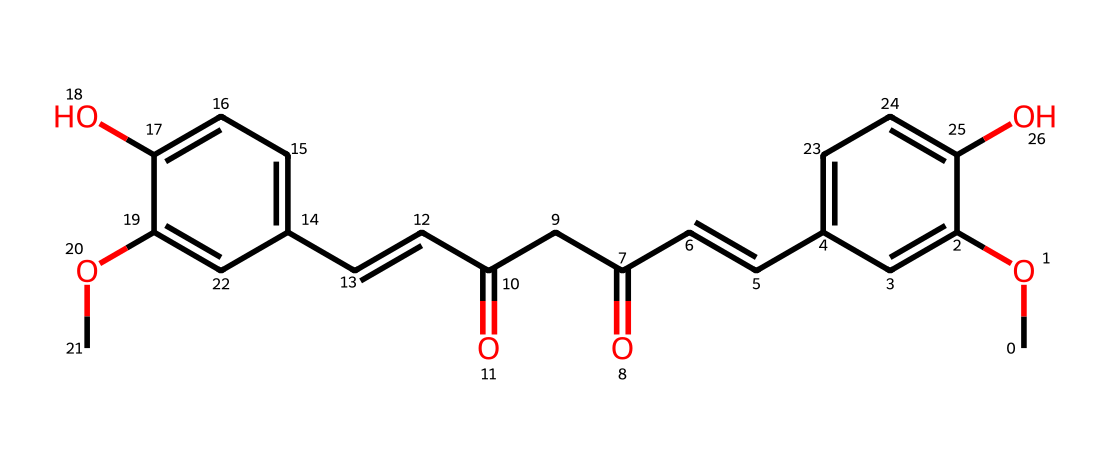What is the molecular formula of curcumin? The SMILES representation can be converted to a molecular formula by identifying the number of each type of atom present in the structure. The given SMILES contains carbon (C), hydrogen (H), and oxygen (O) atoms. Counting these gives a molecular formula of C21H20O6.
Answer: C21H20O6 How many hydroxyl (-OH) groups are present in curcumin? By examining the SMILES representation, we can identify the presence of -OH groups by looking for "O" atoms that are connected to a carbon atom. In this case, there are two distinct -OH groups present in the structure.
Answer: 2 What type of chemical compound is curcumin classified as? Curcumin is a polyphenolic compound due to the presence of multiple phenolic groups in its structure. This classification is based on its chemical structure which includes phenolic rings.
Answer: polyphenol Which part of curcumin is responsible for its antioxidant activity? The presence of phenolic hydroxyl groups is typically linked to antioxidant activity. In curcumin, the hydroxyl (-OH) groups on the phenolic rings are primarily responsible for its antioxidant properties.
Answer: hydroxyl groups What is the total number of carbon atoms in curcumin? By counting the "C" components in the SMILES representation, we find that the total number of carbon atoms in the molecular structure is 21.
Answer: 21 Based on its structure, how many conjugated double bonds are there in curcumin? The presence of double bonds can be identified in the SMILES notation by looking for "/C=C/" notations. In this specific structure, there are two conjugated double bonds.
Answer: 2 